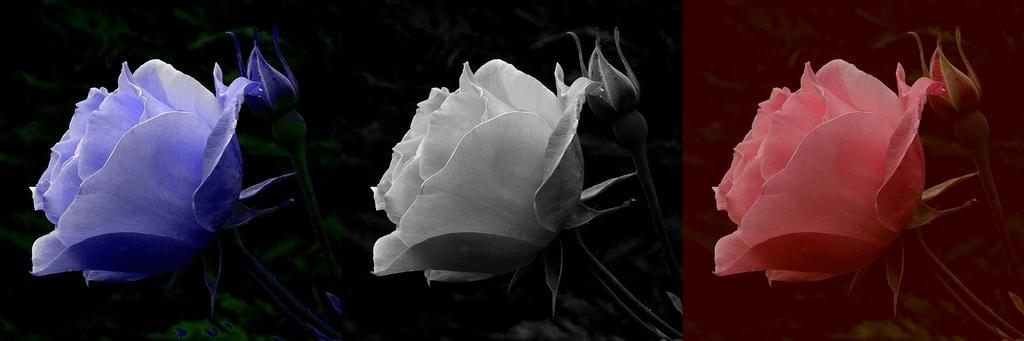Describe this image in one or two sentences. This is the collage of three images. In the first image we can see blue color flowers, stems and leaves. The second image is black and white where we can see flowers and stems. In the third image, pink color flowers and stems are there. 